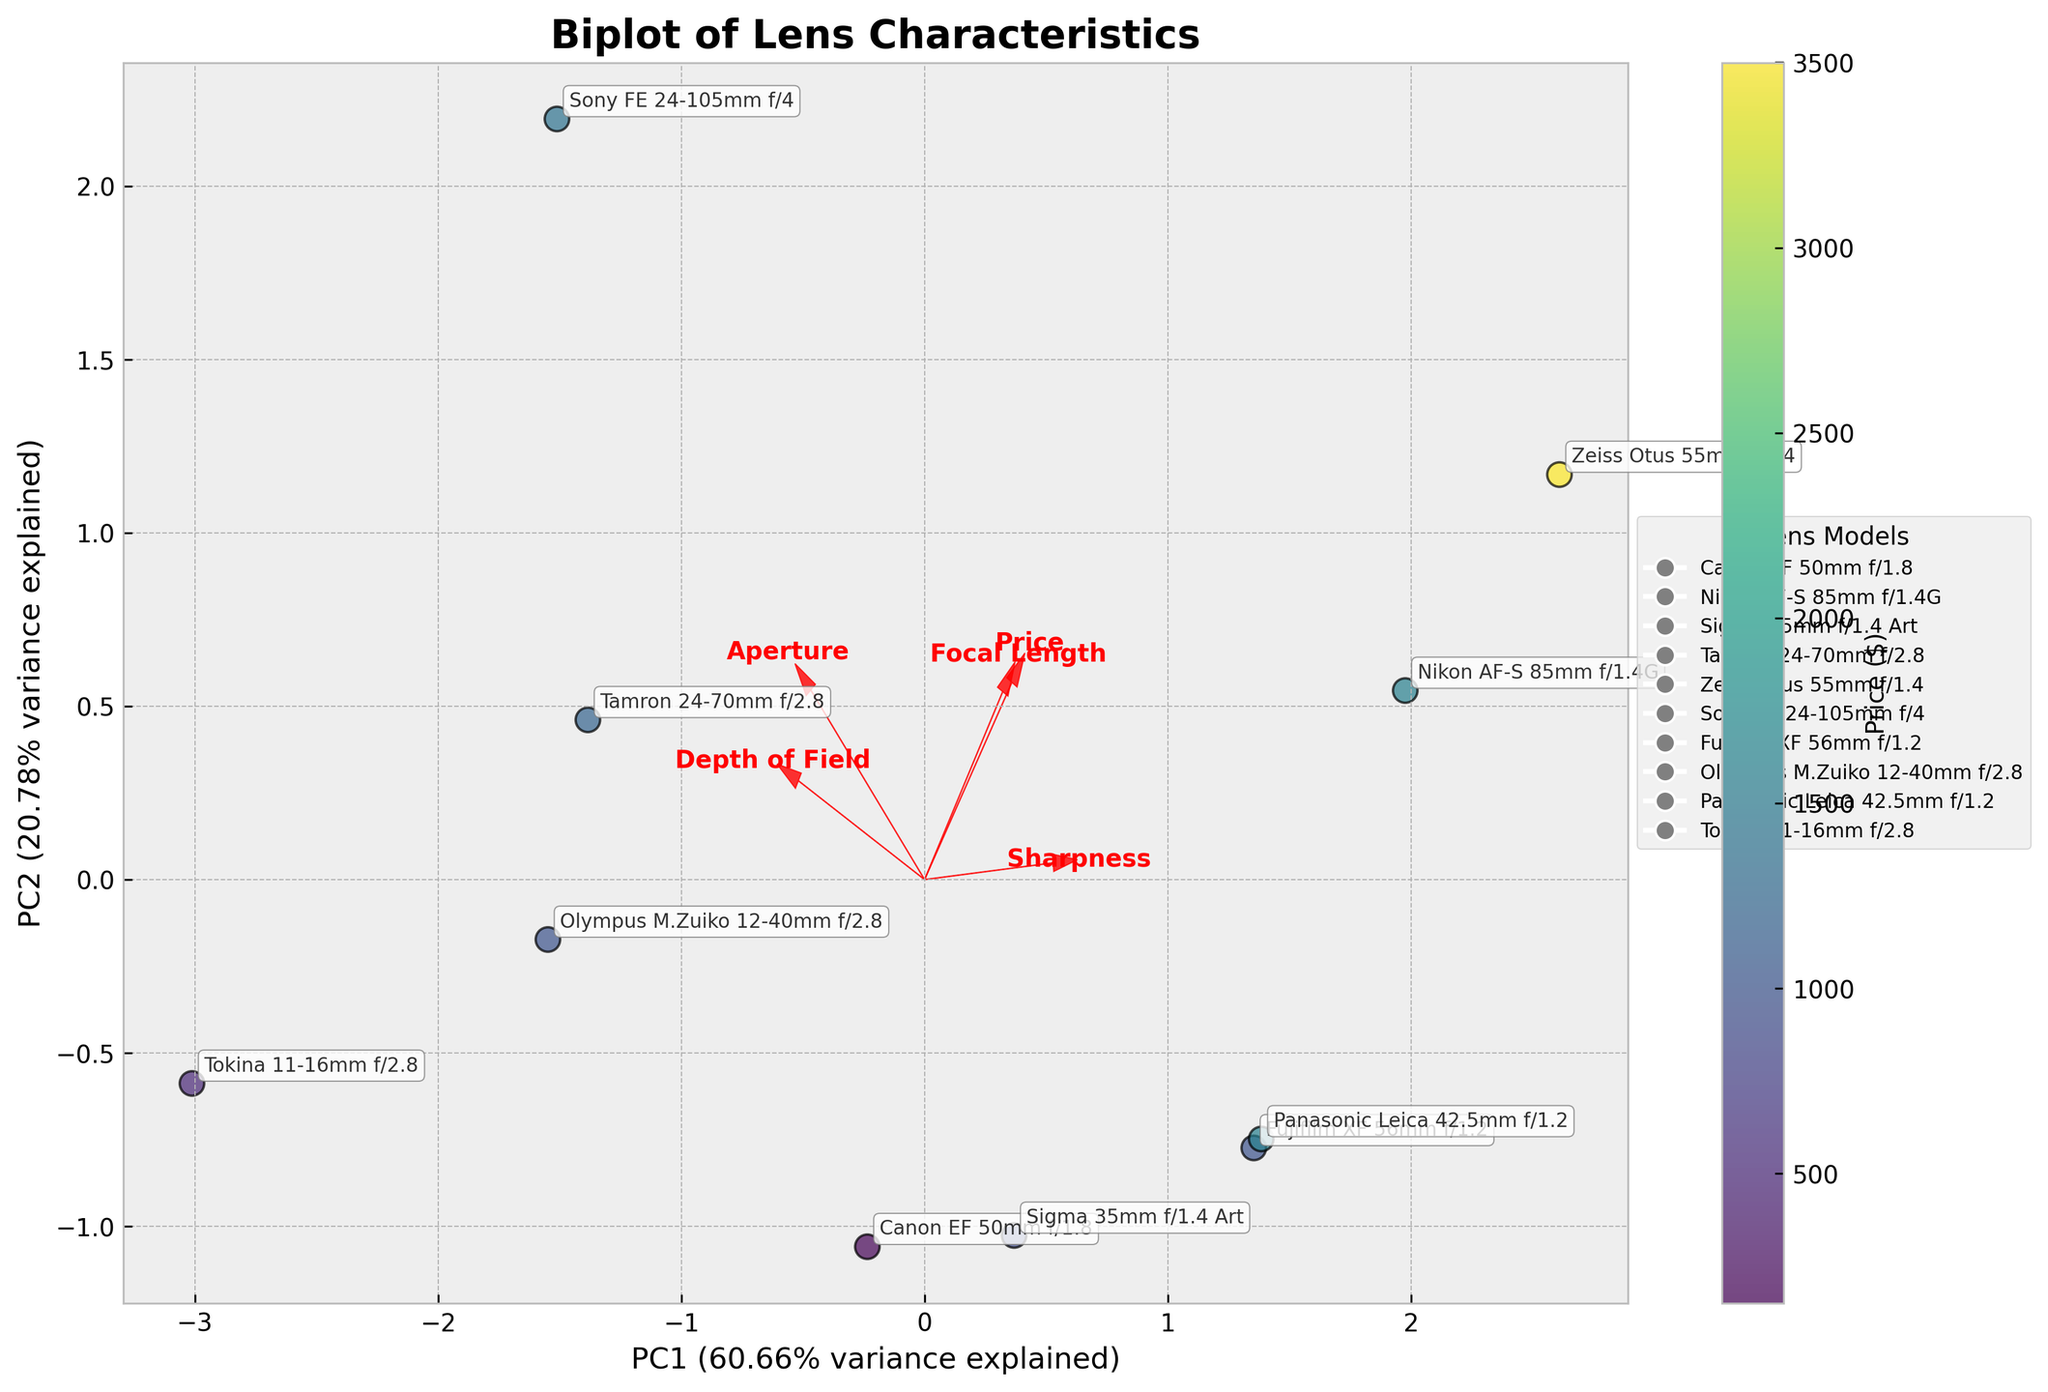How many lenses are represented in the plot? Count the number of unique annotations on the plot. Each annotation represents a lens name.
Answer: 10 What is the title of the plot? Look at the top of the plot where the title is usually located.
Answer: Biplot of Lens Characteristics Which dimension explains the largest variance? Compare the percentages of variance explained, labeled along the x-axis (PC1) and y-axis (PC2). The axis with the higher percentage explains the largest variance.
Answer: PC1 Which lens has the highest price, and where is it located on the plot? Look at the annotations and the color bar. The lens with the darkest color represents the highest price. Locate this lens in the plot.
Answer: Zeiss Otus 55mm f/1.4, near the top-left quadrant What does the color of the points represent, and which lens has the lowest price? Refer to the color bar near the plot, which indicates the price. The point with the corresponding lightest color has the lowest price.
Answer: The color represents Price; Canon EF 50mm f/1.8 has the lowest price How is Sharpness indicated in the plot? Check the direction and label of the red arrows representing features. The arrow labeled 'Sharpness' shows the direction in which sharpness is represented in the plot.
Answer: Represented by the direction and magnitude of one of the red arrows labeled 'Sharpness' Which lens has the greatest depth of field, and where is it located? Look for the lens with the highest value on the scale of Depth of Field on the plot.
Answer: Tokina 11-16mm f/2.8, near the center-right quadrant What does an arrow on a biplot indicate, and what information can be derived from its length and direction? Arrows represent the loadings of the features. The length shows the strength of the variable's influence, and the direction indicates the correlation between the components and the features.
Answer: Arrows indicate loadings of features; length shows feature influence, direction shows correlation Compare the sharpness of the Canon EF 50mm f/1.8 and the Sigma 35mm f/1.4 Art lenses. Locate both lenses on the plot and refer to the position relative to the sharpness vector. The closer a lens is to the sharpness arrow, the sharper it is.
Answer: Sigma 35mm f/1.4 Art is sharper What relationship can be observed between focal length and depth of field? Look at the directions of the arrows for 'Focal Length' and 'Depth of Field'. If the arrows are in different directions, there is an inverse relationship.
Answer: Inverse relationship 